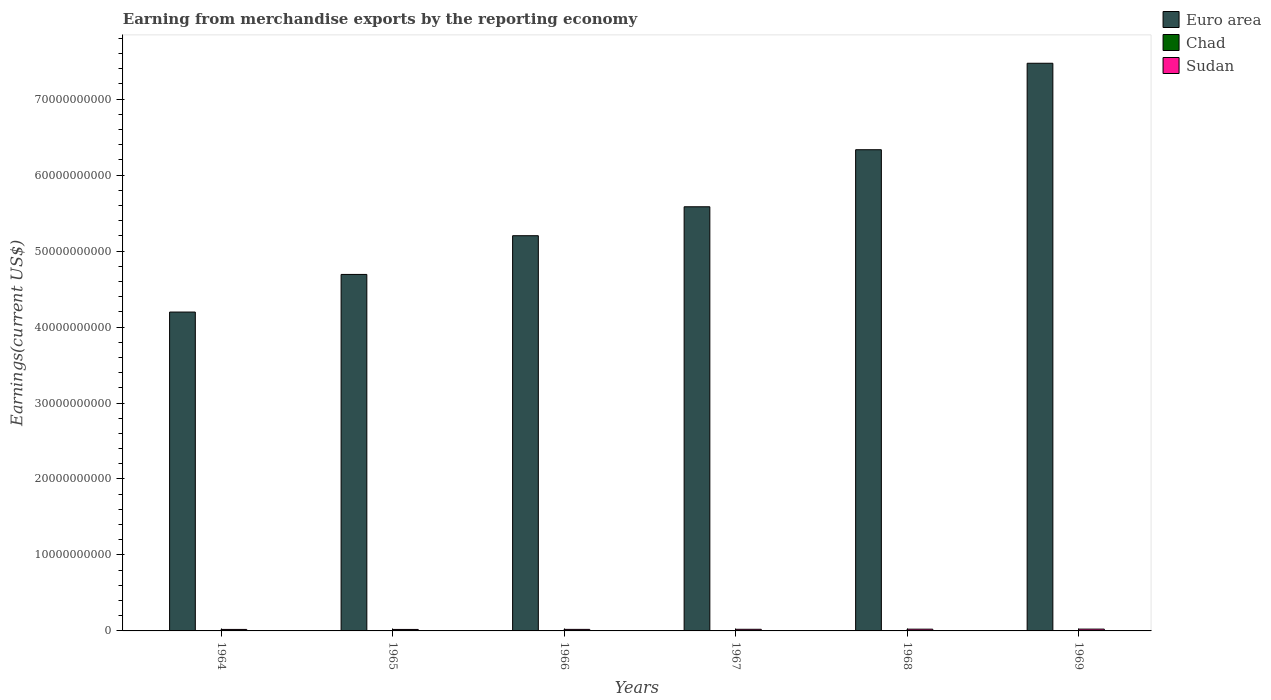How many groups of bars are there?
Your answer should be very brief. 6. Are the number of bars per tick equal to the number of legend labels?
Your response must be concise. Yes. What is the label of the 4th group of bars from the left?
Give a very brief answer. 1967. What is the amount earned from merchandise exports in Euro area in 1969?
Offer a terse response. 7.47e+1. Across all years, what is the maximum amount earned from merchandise exports in Euro area?
Make the answer very short. 7.47e+1. Across all years, what is the minimum amount earned from merchandise exports in Chad?
Your answer should be compact. 2.38e+07. In which year was the amount earned from merchandise exports in Sudan maximum?
Provide a succinct answer. 1969. In which year was the amount earned from merchandise exports in Euro area minimum?
Ensure brevity in your answer.  1964. What is the total amount earned from merchandise exports in Chad in the graph?
Make the answer very short. 1.68e+08. What is the difference between the amount earned from merchandise exports in Chad in 1966 and that in 1969?
Offer a very short reply. -8.98e+06. What is the difference between the amount earned from merchandise exports in Sudan in 1965 and the amount earned from merchandise exports in Chad in 1969?
Your answer should be very brief. 1.62e+08. What is the average amount earned from merchandise exports in Euro area per year?
Make the answer very short. 5.58e+1. In the year 1969, what is the difference between the amount earned from merchandise exports in Chad and amount earned from merchandise exports in Euro area?
Offer a terse response. -7.47e+1. What is the ratio of the amount earned from merchandise exports in Chad in 1966 to that in 1968?
Make the answer very short. 0.78. Is the amount earned from merchandise exports in Chad in 1965 less than that in 1969?
Your answer should be compact. Yes. Is the difference between the amount earned from merchandise exports in Chad in 1967 and 1968 greater than the difference between the amount earned from merchandise exports in Euro area in 1967 and 1968?
Provide a short and direct response. Yes. What is the difference between the highest and the second highest amount earned from merchandise exports in Chad?
Your answer should be very brief. 2.28e+06. What is the difference between the highest and the lowest amount earned from merchandise exports in Euro area?
Make the answer very short. 3.28e+1. In how many years, is the amount earned from merchandise exports in Euro area greater than the average amount earned from merchandise exports in Euro area taken over all years?
Provide a succinct answer. 3. Is the sum of the amount earned from merchandise exports in Euro area in 1966 and 1968 greater than the maximum amount earned from merchandise exports in Sudan across all years?
Provide a short and direct response. Yes. What does the 2nd bar from the right in 1969 represents?
Ensure brevity in your answer.  Chad. Is it the case that in every year, the sum of the amount earned from merchandise exports in Euro area and amount earned from merchandise exports in Sudan is greater than the amount earned from merchandise exports in Chad?
Give a very brief answer. Yes. How many bars are there?
Your answer should be compact. 18. How many years are there in the graph?
Offer a terse response. 6. What is the difference between two consecutive major ticks on the Y-axis?
Make the answer very short. 1.00e+1. Does the graph contain any zero values?
Ensure brevity in your answer.  No. Where does the legend appear in the graph?
Provide a succinct answer. Top right. How many legend labels are there?
Your answer should be compact. 3. How are the legend labels stacked?
Offer a terse response. Vertical. What is the title of the graph?
Offer a terse response. Earning from merchandise exports by the reporting economy. Does "Spain" appear as one of the legend labels in the graph?
Ensure brevity in your answer.  No. What is the label or title of the X-axis?
Give a very brief answer. Years. What is the label or title of the Y-axis?
Provide a short and direct response. Earnings(current US$). What is the Earnings(current US$) of Euro area in 1964?
Make the answer very short. 4.20e+1. What is the Earnings(current US$) in Chad in 1964?
Keep it short and to the point. 2.65e+07. What is the Earnings(current US$) of Sudan in 1964?
Provide a succinct answer. 1.96e+08. What is the Earnings(current US$) of Euro area in 1965?
Make the answer very short. 4.69e+1. What is the Earnings(current US$) of Chad in 1965?
Your answer should be very brief. 2.71e+07. What is the Earnings(current US$) of Sudan in 1965?
Keep it short and to the point. 1.95e+08. What is the Earnings(current US$) of Euro area in 1966?
Ensure brevity in your answer.  5.20e+1. What is the Earnings(current US$) in Chad in 1966?
Offer a terse response. 2.38e+07. What is the Earnings(current US$) of Sudan in 1966?
Offer a terse response. 2.03e+08. What is the Earnings(current US$) in Euro area in 1967?
Make the answer very short. 5.58e+1. What is the Earnings(current US$) in Chad in 1967?
Provide a succinct answer. 2.69e+07. What is the Earnings(current US$) in Sudan in 1967?
Provide a succinct answer. 2.14e+08. What is the Earnings(current US$) in Euro area in 1968?
Offer a very short reply. 6.33e+1. What is the Earnings(current US$) of Chad in 1968?
Keep it short and to the point. 3.05e+07. What is the Earnings(current US$) of Sudan in 1968?
Your response must be concise. 2.32e+08. What is the Earnings(current US$) in Euro area in 1969?
Offer a terse response. 7.47e+1. What is the Earnings(current US$) in Chad in 1969?
Offer a terse response. 3.28e+07. What is the Earnings(current US$) of Sudan in 1969?
Make the answer very short. 2.40e+08. Across all years, what is the maximum Earnings(current US$) in Euro area?
Keep it short and to the point. 7.47e+1. Across all years, what is the maximum Earnings(current US$) in Chad?
Offer a very short reply. 3.28e+07. Across all years, what is the maximum Earnings(current US$) in Sudan?
Give a very brief answer. 2.40e+08. Across all years, what is the minimum Earnings(current US$) of Euro area?
Offer a terse response. 4.20e+1. Across all years, what is the minimum Earnings(current US$) in Chad?
Your answer should be very brief. 2.38e+07. Across all years, what is the minimum Earnings(current US$) of Sudan?
Make the answer very short. 1.95e+08. What is the total Earnings(current US$) of Euro area in the graph?
Offer a terse response. 3.35e+11. What is the total Earnings(current US$) of Chad in the graph?
Provide a succinct answer. 1.68e+08. What is the total Earnings(current US$) of Sudan in the graph?
Offer a very short reply. 1.28e+09. What is the difference between the Earnings(current US$) in Euro area in 1964 and that in 1965?
Provide a succinct answer. -4.95e+09. What is the difference between the Earnings(current US$) in Chad in 1964 and that in 1965?
Provide a succinct answer. -6.00e+05. What is the difference between the Earnings(current US$) of Sudan in 1964 and that in 1965?
Your response must be concise. 1.30e+06. What is the difference between the Earnings(current US$) in Euro area in 1964 and that in 1966?
Your answer should be compact. -1.01e+1. What is the difference between the Earnings(current US$) in Chad in 1964 and that in 1966?
Offer a very short reply. 2.70e+06. What is the difference between the Earnings(current US$) in Sudan in 1964 and that in 1966?
Your answer should be compact. -6.30e+06. What is the difference between the Earnings(current US$) of Euro area in 1964 and that in 1967?
Make the answer very short. -1.39e+1. What is the difference between the Earnings(current US$) in Chad in 1964 and that in 1967?
Give a very brief answer. -4.00e+05. What is the difference between the Earnings(current US$) in Sudan in 1964 and that in 1967?
Ensure brevity in your answer.  -1.77e+07. What is the difference between the Earnings(current US$) in Euro area in 1964 and that in 1968?
Your answer should be compact. -2.14e+1. What is the difference between the Earnings(current US$) in Chad in 1964 and that in 1968?
Offer a very short reply. -4.00e+06. What is the difference between the Earnings(current US$) in Sudan in 1964 and that in 1968?
Give a very brief answer. -3.59e+07. What is the difference between the Earnings(current US$) of Euro area in 1964 and that in 1969?
Provide a succinct answer. -3.28e+1. What is the difference between the Earnings(current US$) in Chad in 1964 and that in 1969?
Offer a very short reply. -6.28e+06. What is the difference between the Earnings(current US$) of Sudan in 1964 and that in 1969?
Your response must be concise. -4.38e+07. What is the difference between the Earnings(current US$) in Euro area in 1965 and that in 1966?
Provide a short and direct response. -5.10e+09. What is the difference between the Earnings(current US$) of Chad in 1965 and that in 1966?
Make the answer very short. 3.30e+06. What is the difference between the Earnings(current US$) in Sudan in 1965 and that in 1966?
Your answer should be very brief. -7.60e+06. What is the difference between the Earnings(current US$) of Euro area in 1965 and that in 1967?
Your response must be concise. -8.91e+09. What is the difference between the Earnings(current US$) of Chad in 1965 and that in 1967?
Keep it short and to the point. 2.00e+05. What is the difference between the Earnings(current US$) in Sudan in 1965 and that in 1967?
Keep it short and to the point. -1.90e+07. What is the difference between the Earnings(current US$) of Euro area in 1965 and that in 1968?
Your response must be concise. -1.64e+1. What is the difference between the Earnings(current US$) of Chad in 1965 and that in 1968?
Provide a short and direct response. -3.40e+06. What is the difference between the Earnings(current US$) of Sudan in 1965 and that in 1968?
Provide a succinct answer. -3.72e+07. What is the difference between the Earnings(current US$) of Euro area in 1965 and that in 1969?
Ensure brevity in your answer.  -2.78e+1. What is the difference between the Earnings(current US$) of Chad in 1965 and that in 1969?
Ensure brevity in your answer.  -5.68e+06. What is the difference between the Earnings(current US$) of Sudan in 1965 and that in 1969?
Provide a short and direct response. -4.51e+07. What is the difference between the Earnings(current US$) of Euro area in 1966 and that in 1967?
Provide a succinct answer. -3.81e+09. What is the difference between the Earnings(current US$) of Chad in 1966 and that in 1967?
Give a very brief answer. -3.10e+06. What is the difference between the Earnings(current US$) of Sudan in 1966 and that in 1967?
Provide a short and direct response. -1.14e+07. What is the difference between the Earnings(current US$) in Euro area in 1966 and that in 1968?
Give a very brief answer. -1.13e+1. What is the difference between the Earnings(current US$) in Chad in 1966 and that in 1968?
Provide a short and direct response. -6.70e+06. What is the difference between the Earnings(current US$) in Sudan in 1966 and that in 1968?
Your answer should be compact. -2.96e+07. What is the difference between the Earnings(current US$) of Euro area in 1966 and that in 1969?
Your response must be concise. -2.27e+1. What is the difference between the Earnings(current US$) in Chad in 1966 and that in 1969?
Make the answer very short. -8.98e+06. What is the difference between the Earnings(current US$) of Sudan in 1966 and that in 1969?
Your answer should be very brief. -3.75e+07. What is the difference between the Earnings(current US$) of Euro area in 1967 and that in 1968?
Offer a very short reply. -7.51e+09. What is the difference between the Earnings(current US$) of Chad in 1967 and that in 1968?
Keep it short and to the point. -3.60e+06. What is the difference between the Earnings(current US$) of Sudan in 1967 and that in 1968?
Provide a succinct answer. -1.82e+07. What is the difference between the Earnings(current US$) of Euro area in 1967 and that in 1969?
Offer a terse response. -1.89e+1. What is the difference between the Earnings(current US$) in Chad in 1967 and that in 1969?
Your answer should be very brief. -5.88e+06. What is the difference between the Earnings(current US$) in Sudan in 1967 and that in 1969?
Provide a short and direct response. -2.61e+07. What is the difference between the Earnings(current US$) of Euro area in 1968 and that in 1969?
Offer a terse response. -1.14e+1. What is the difference between the Earnings(current US$) of Chad in 1968 and that in 1969?
Your response must be concise. -2.28e+06. What is the difference between the Earnings(current US$) in Sudan in 1968 and that in 1969?
Offer a terse response. -7.89e+06. What is the difference between the Earnings(current US$) of Euro area in 1964 and the Earnings(current US$) of Chad in 1965?
Your answer should be very brief. 4.19e+1. What is the difference between the Earnings(current US$) in Euro area in 1964 and the Earnings(current US$) in Sudan in 1965?
Provide a short and direct response. 4.18e+1. What is the difference between the Earnings(current US$) of Chad in 1964 and the Earnings(current US$) of Sudan in 1965?
Provide a short and direct response. -1.69e+08. What is the difference between the Earnings(current US$) of Euro area in 1964 and the Earnings(current US$) of Chad in 1966?
Provide a succinct answer. 4.19e+1. What is the difference between the Earnings(current US$) of Euro area in 1964 and the Earnings(current US$) of Sudan in 1966?
Your response must be concise. 4.18e+1. What is the difference between the Earnings(current US$) in Chad in 1964 and the Earnings(current US$) in Sudan in 1966?
Ensure brevity in your answer.  -1.76e+08. What is the difference between the Earnings(current US$) in Euro area in 1964 and the Earnings(current US$) in Chad in 1967?
Make the answer very short. 4.19e+1. What is the difference between the Earnings(current US$) of Euro area in 1964 and the Earnings(current US$) of Sudan in 1967?
Provide a short and direct response. 4.18e+1. What is the difference between the Earnings(current US$) of Chad in 1964 and the Earnings(current US$) of Sudan in 1967?
Offer a terse response. -1.88e+08. What is the difference between the Earnings(current US$) in Euro area in 1964 and the Earnings(current US$) in Chad in 1968?
Your response must be concise. 4.19e+1. What is the difference between the Earnings(current US$) in Euro area in 1964 and the Earnings(current US$) in Sudan in 1968?
Give a very brief answer. 4.17e+1. What is the difference between the Earnings(current US$) of Chad in 1964 and the Earnings(current US$) of Sudan in 1968?
Keep it short and to the point. -2.06e+08. What is the difference between the Earnings(current US$) of Euro area in 1964 and the Earnings(current US$) of Chad in 1969?
Ensure brevity in your answer.  4.19e+1. What is the difference between the Earnings(current US$) in Euro area in 1964 and the Earnings(current US$) in Sudan in 1969?
Make the answer very short. 4.17e+1. What is the difference between the Earnings(current US$) of Chad in 1964 and the Earnings(current US$) of Sudan in 1969?
Your answer should be very brief. -2.14e+08. What is the difference between the Earnings(current US$) in Euro area in 1965 and the Earnings(current US$) in Chad in 1966?
Give a very brief answer. 4.69e+1. What is the difference between the Earnings(current US$) in Euro area in 1965 and the Earnings(current US$) in Sudan in 1966?
Your answer should be very brief. 4.67e+1. What is the difference between the Earnings(current US$) of Chad in 1965 and the Earnings(current US$) of Sudan in 1966?
Offer a very short reply. -1.76e+08. What is the difference between the Earnings(current US$) of Euro area in 1965 and the Earnings(current US$) of Chad in 1967?
Offer a very short reply. 4.69e+1. What is the difference between the Earnings(current US$) of Euro area in 1965 and the Earnings(current US$) of Sudan in 1967?
Keep it short and to the point. 4.67e+1. What is the difference between the Earnings(current US$) in Chad in 1965 and the Earnings(current US$) in Sudan in 1967?
Provide a short and direct response. -1.87e+08. What is the difference between the Earnings(current US$) of Euro area in 1965 and the Earnings(current US$) of Chad in 1968?
Offer a terse response. 4.69e+1. What is the difference between the Earnings(current US$) of Euro area in 1965 and the Earnings(current US$) of Sudan in 1968?
Your answer should be very brief. 4.67e+1. What is the difference between the Earnings(current US$) in Chad in 1965 and the Earnings(current US$) in Sudan in 1968?
Provide a short and direct response. -2.05e+08. What is the difference between the Earnings(current US$) in Euro area in 1965 and the Earnings(current US$) in Chad in 1969?
Give a very brief answer. 4.69e+1. What is the difference between the Earnings(current US$) of Euro area in 1965 and the Earnings(current US$) of Sudan in 1969?
Offer a terse response. 4.67e+1. What is the difference between the Earnings(current US$) in Chad in 1965 and the Earnings(current US$) in Sudan in 1969?
Provide a short and direct response. -2.13e+08. What is the difference between the Earnings(current US$) of Euro area in 1966 and the Earnings(current US$) of Chad in 1967?
Your answer should be very brief. 5.20e+1. What is the difference between the Earnings(current US$) of Euro area in 1966 and the Earnings(current US$) of Sudan in 1967?
Offer a very short reply. 5.18e+1. What is the difference between the Earnings(current US$) of Chad in 1966 and the Earnings(current US$) of Sudan in 1967?
Give a very brief answer. -1.90e+08. What is the difference between the Earnings(current US$) of Euro area in 1966 and the Earnings(current US$) of Chad in 1968?
Provide a short and direct response. 5.20e+1. What is the difference between the Earnings(current US$) in Euro area in 1966 and the Earnings(current US$) in Sudan in 1968?
Ensure brevity in your answer.  5.18e+1. What is the difference between the Earnings(current US$) of Chad in 1966 and the Earnings(current US$) of Sudan in 1968?
Your answer should be compact. -2.08e+08. What is the difference between the Earnings(current US$) of Euro area in 1966 and the Earnings(current US$) of Chad in 1969?
Ensure brevity in your answer.  5.20e+1. What is the difference between the Earnings(current US$) in Euro area in 1966 and the Earnings(current US$) in Sudan in 1969?
Give a very brief answer. 5.18e+1. What is the difference between the Earnings(current US$) of Chad in 1966 and the Earnings(current US$) of Sudan in 1969?
Make the answer very short. -2.16e+08. What is the difference between the Earnings(current US$) of Euro area in 1967 and the Earnings(current US$) of Chad in 1968?
Ensure brevity in your answer.  5.58e+1. What is the difference between the Earnings(current US$) of Euro area in 1967 and the Earnings(current US$) of Sudan in 1968?
Offer a terse response. 5.56e+1. What is the difference between the Earnings(current US$) in Chad in 1967 and the Earnings(current US$) in Sudan in 1968?
Offer a terse response. -2.05e+08. What is the difference between the Earnings(current US$) of Euro area in 1967 and the Earnings(current US$) of Chad in 1969?
Your answer should be very brief. 5.58e+1. What is the difference between the Earnings(current US$) of Euro area in 1967 and the Earnings(current US$) of Sudan in 1969?
Provide a succinct answer. 5.56e+1. What is the difference between the Earnings(current US$) in Chad in 1967 and the Earnings(current US$) in Sudan in 1969?
Offer a terse response. -2.13e+08. What is the difference between the Earnings(current US$) in Euro area in 1968 and the Earnings(current US$) in Chad in 1969?
Offer a terse response. 6.33e+1. What is the difference between the Earnings(current US$) in Euro area in 1968 and the Earnings(current US$) in Sudan in 1969?
Make the answer very short. 6.31e+1. What is the difference between the Earnings(current US$) of Chad in 1968 and the Earnings(current US$) of Sudan in 1969?
Ensure brevity in your answer.  -2.10e+08. What is the average Earnings(current US$) in Euro area per year?
Offer a very short reply. 5.58e+1. What is the average Earnings(current US$) in Chad per year?
Your answer should be compact. 2.79e+07. What is the average Earnings(current US$) in Sudan per year?
Offer a very short reply. 2.13e+08. In the year 1964, what is the difference between the Earnings(current US$) of Euro area and Earnings(current US$) of Chad?
Offer a terse response. 4.19e+1. In the year 1964, what is the difference between the Earnings(current US$) in Euro area and Earnings(current US$) in Sudan?
Ensure brevity in your answer.  4.18e+1. In the year 1964, what is the difference between the Earnings(current US$) of Chad and Earnings(current US$) of Sudan?
Your answer should be compact. -1.70e+08. In the year 1965, what is the difference between the Earnings(current US$) in Euro area and Earnings(current US$) in Chad?
Give a very brief answer. 4.69e+1. In the year 1965, what is the difference between the Earnings(current US$) in Euro area and Earnings(current US$) in Sudan?
Your response must be concise. 4.67e+1. In the year 1965, what is the difference between the Earnings(current US$) in Chad and Earnings(current US$) in Sudan?
Offer a very short reply. -1.68e+08. In the year 1966, what is the difference between the Earnings(current US$) of Euro area and Earnings(current US$) of Chad?
Your answer should be compact. 5.20e+1. In the year 1966, what is the difference between the Earnings(current US$) of Euro area and Earnings(current US$) of Sudan?
Provide a short and direct response. 5.18e+1. In the year 1966, what is the difference between the Earnings(current US$) of Chad and Earnings(current US$) of Sudan?
Provide a succinct answer. -1.79e+08. In the year 1967, what is the difference between the Earnings(current US$) of Euro area and Earnings(current US$) of Chad?
Keep it short and to the point. 5.58e+1. In the year 1967, what is the difference between the Earnings(current US$) in Euro area and Earnings(current US$) in Sudan?
Your answer should be compact. 5.56e+1. In the year 1967, what is the difference between the Earnings(current US$) in Chad and Earnings(current US$) in Sudan?
Your response must be concise. -1.87e+08. In the year 1968, what is the difference between the Earnings(current US$) of Euro area and Earnings(current US$) of Chad?
Your answer should be compact. 6.33e+1. In the year 1968, what is the difference between the Earnings(current US$) of Euro area and Earnings(current US$) of Sudan?
Offer a very short reply. 6.31e+1. In the year 1968, what is the difference between the Earnings(current US$) of Chad and Earnings(current US$) of Sudan?
Make the answer very short. -2.02e+08. In the year 1969, what is the difference between the Earnings(current US$) of Euro area and Earnings(current US$) of Chad?
Provide a succinct answer. 7.47e+1. In the year 1969, what is the difference between the Earnings(current US$) in Euro area and Earnings(current US$) in Sudan?
Your response must be concise. 7.45e+1. In the year 1969, what is the difference between the Earnings(current US$) in Chad and Earnings(current US$) in Sudan?
Offer a terse response. -2.07e+08. What is the ratio of the Earnings(current US$) in Euro area in 1964 to that in 1965?
Keep it short and to the point. 0.89. What is the ratio of the Earnings(current US$) in Chad in 1964 to that in 1965?
Make the answer very short. 0.98. What is the ratio of the Earnings(current US$) in Sudan in 1964 to that in 1965?
Give a very brief answer. 1.01. What is the ratio of the Earnings(current US$) of Euro area in 1964 to that in 1966?
Give a very brief answer. 0.81. What is the ratio of the Earnings(current US$) of Chad in 1964 to that in 1966?
Your response must be concise. 1.11. What is the ratio of the Earnings(current US$) of Sudan in 1964 to that in 1966?
Provide a short and direct response. 0.97. What is the ratio of the Earnings(current US$) in Euro area in 1964 to that in 1967?
Give a very brief answer. 0.75. What is the ratio of the Earnings(current US$) of Chad in 1964 to that in 1967?
Make the answer very short. 0.99. What is the ratio of the Earnings(current US$) of Sudan in 1964 to that in 1967?
Ensure brevity in your answer.  0.92. What is the ratio of the Earnings(current US$) in Euro area in 1964 to that in 1968?
Provide a succinct answer. 0.66. What is the ratio of the Earnings(current US$) in Chad in 1964 to that in 1968?
Provide a short and direct response. 0.87. What is the ratio of the Earnings(current US$) in Sudan in 1964 to that in 1968?
Ensure brevity in your answer.  0.85. What is the ratio of the Earnings(current US$) in Euro area in 1964 to that in 1969?
Make the answer very short. 0.56. What is the ratio of the Earnings(current US$) in Chad in 1964 to that in 1969?
Give a very brief answer. 0.81. What is the ratio of the Earnings(current US$) in Sudan in 1964 to that in 1969?
Your response must be concise. 0.82. What is the ratio of the Earnings(current US$) in Euro area in 1965 to that in 1966?
Ensure brevity in your answer.  0.9. What is the ratio of the Earnings(current US$) in Chad in 1965 to that in 1966?
Offer a terse response. 1.14. What is the ratio of the Earnings(current US$) in Sudan in 1965 to that in 1966?
Your answer should be compact. 0.96. What is the ratio of the Earnings(current US$) in Euro area in 1965 to that in 1967?
Your response must be concise. 0.84. What is the ratio of the Earnings(current US$) of Chad in 1965 to that in 1967?
Ensure brevity in your answer.  1.01. What is the ratio of the Earnings(current US$) in Sudan in 1965 to that in 1967?
Provide a succinct answer. 0.91. What is the ratio of the Earnings(current US$) in Euro area in 1965 to that in 1968?
Your answer should be very brief. 0.74. What is the ratio of the Earnings(current US$) of Chad in 1965 to that in 1968?
Provide a short and direct response. 0.89. What is the ratio of the Earnings(current US$) of Sudan in 1965 to that in 1968?
Ensure brevity in your answer.  0.84. What is the ratio of the Earnings(current US$) of Euro area in 1965 to that in 1969?
Make the answer very short. 0.63. What is the ratio of the Earnings(current US$) in Chad in 1965 to that in 1969?
Keep it short and to the point. 0.83. What is the ratio of the Earnings(current US$) of Sudan in 1965 to that in 1969?
Offer a very short reply. 0.81. What is the ratio of the Earnings(current US$) of Euro area in 1966 to that in 1967?
Your answer should be compact. 0.93. What is the ratio of the Earnings(current US$) of Chad in 1966 to that in 1967?
Give a very brief answer. 0.88. What is the ratio of the Earnings(current US$) of Sudan in 1966 to that in 1967?
Provide a succinct answer. 0.95. What is the ratio of the Earnings(current US$) in Euro area in 1966 to that in 1968?
Make the answer very short. 0.82. What is the ratio of the Earnings(current US$) in Chad in 1966 to that in 1968?
Provide a succinct answer. 0.78. What is the ratio of the Earnings(current US$) in Sudan in 1966 to that in 1968?
Offer a very short reply. 0.87. What is the ratio of the Earnings(current US$) of Euro area in 1966 to that in 1969?
Your answer should be very brief. 0.7. What is the ratio of the Earnings(current US$) in Chad in 1966 to that in 1969?
Ensure brevity in your answer.  0.73. What is the ratio of the Earnings(current US$) of Sudan in 1966 to that in 1969?
Your answer should be compact. 0.84. What is the ratio of the Earnings(current US$) of Euro area in 1967 to that in 1968?
Offer a terse response. 0.88. What is the ratio of the Earnings(current US$) in Chad in 1967 to that in 1968?
Give a very brief answer. 0.88. What is the ratio of the Earnings(current US$) of Sudan in 1967 to that in 1968?
Your answer should be compact. 0.92. What is the ratio of the Earnings(current US$) of Euro area in 1967 to that in 1969?
Offer a very short reply. 0.75. What is the ratio of the Earnings(current US$) of Chad in 1967 to that in 1969?
Make the answer very short. 0.82. What is the ratio of the Earnings(current US$) in Sudan in 1967 to that in 1969?
Make the answer very short. 0.89. What is the ratio of the Earnings(current US$) in Euro area in 1968 to that in 1969?
Keep it short and to the point. 0.85. What is the ratio of the Earnings(current US$) of Chad in 1968 to that in 1969?
Ensure brevity in your answer.  0.93. What is the ratio of the Earnings(current US$) of Sudan in 1968 to that in 1969?
Offer a terse response. 0.97. What is the difference between the highest and the second highest Earnings(current US$) of Euro area?
Provide a short and direct response. 1.14e+1. What is the difference between the highest and the second highest Earnings(current US$) in Chad?
Offer a terse response. 2.28e+06. What is the difference between the highest and the second highest Earnings(current US$) of Sudan?
Your answer should be compact. 7.89e+06. What is the difference between the highest and the lowest Earnings(current US$) in Euro area?
Your answer should be compact. 3.28e+1. What is the difference between the highest and the lowest Earnings(current US$) of Chad?
Offer a terse response. 8.98e+06. What is the difference between the highest and the lowest Earnings(current US$) in Sudan?
Offer a terse response. 4.51e+07. 